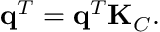Convert formula to latex. <formula><loc_0><loc_0><loc_500><loc_500>q ^ { T } = q ^ { T } K _ { C } .</formula> 